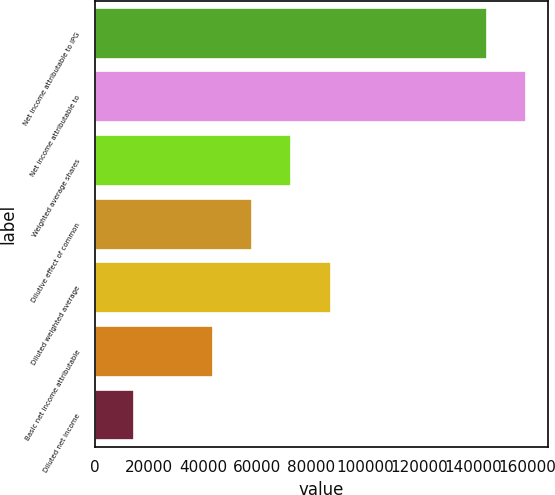Convert chart. <chart><loc_0><loc_0><loc_500><loc_500><bar_chart><fcel>Net income attributable to IPG<fcel>Net income attributable to<fcel>Weighted average shares<fcel>Dilutive effect of common<fcel>Diluted weighted average<fcel>Basic net income attributable<fcel>Diluted net income<nl><fcel>145004<fcel>159553<fcel>72749.9<fcel>58200.5<fcel>87299.3<fcel>43651.1<fcel>14552.2<nl></chart> 